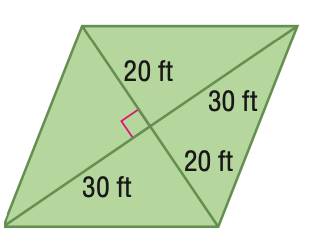Question: Find the area of the figure. Round to the nearest tenth if necessary.
Choices:
A. 600
B. 900
C. 1200
D. 2400
Answer with the letter. Answer: C 